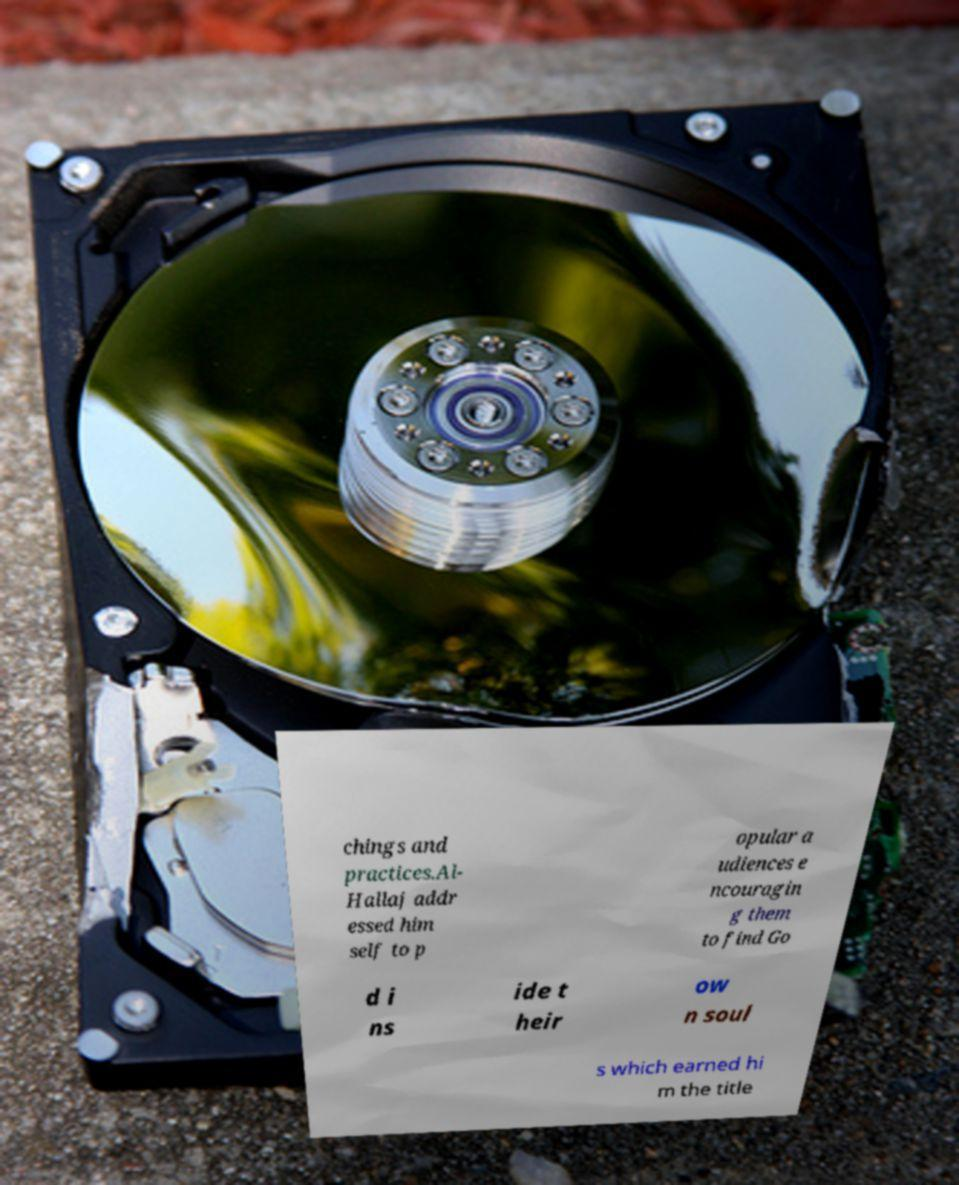I need the written content from this picture converted into text. Can you do that? chings and practices.Al- Hallaj addr essed him self to p opular a udiences e ncouragin g them to find Go d i ns ide t heir ow n soul s which earned hi m the title 